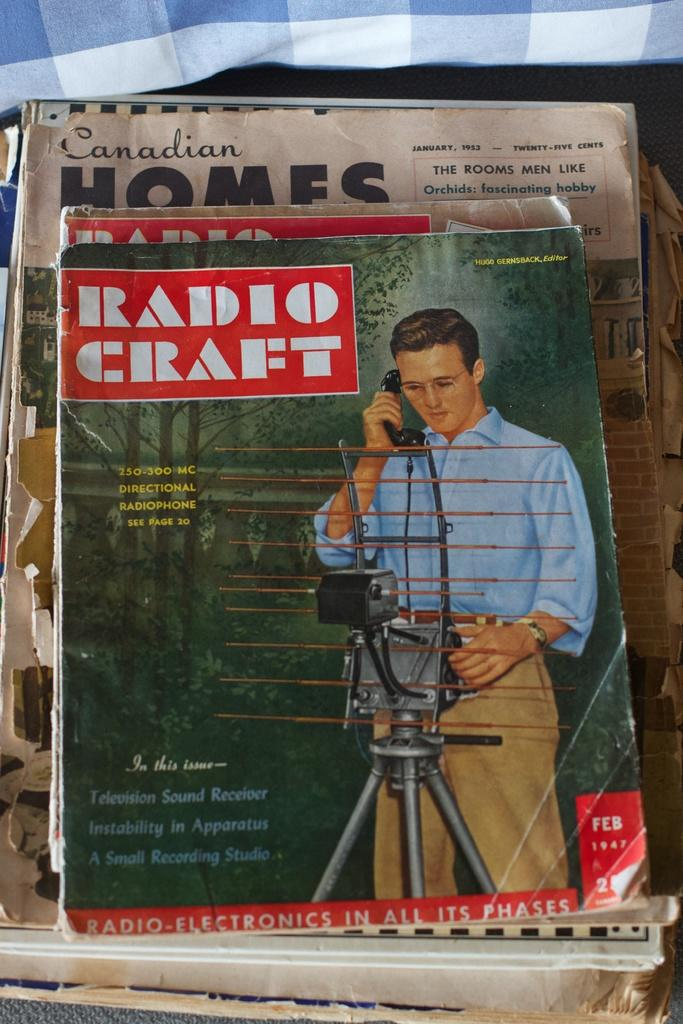Provide a one-sentence caption for the provided image. A stack of Radio Craft magazines are piled on top of Canadian Homes magazine. 